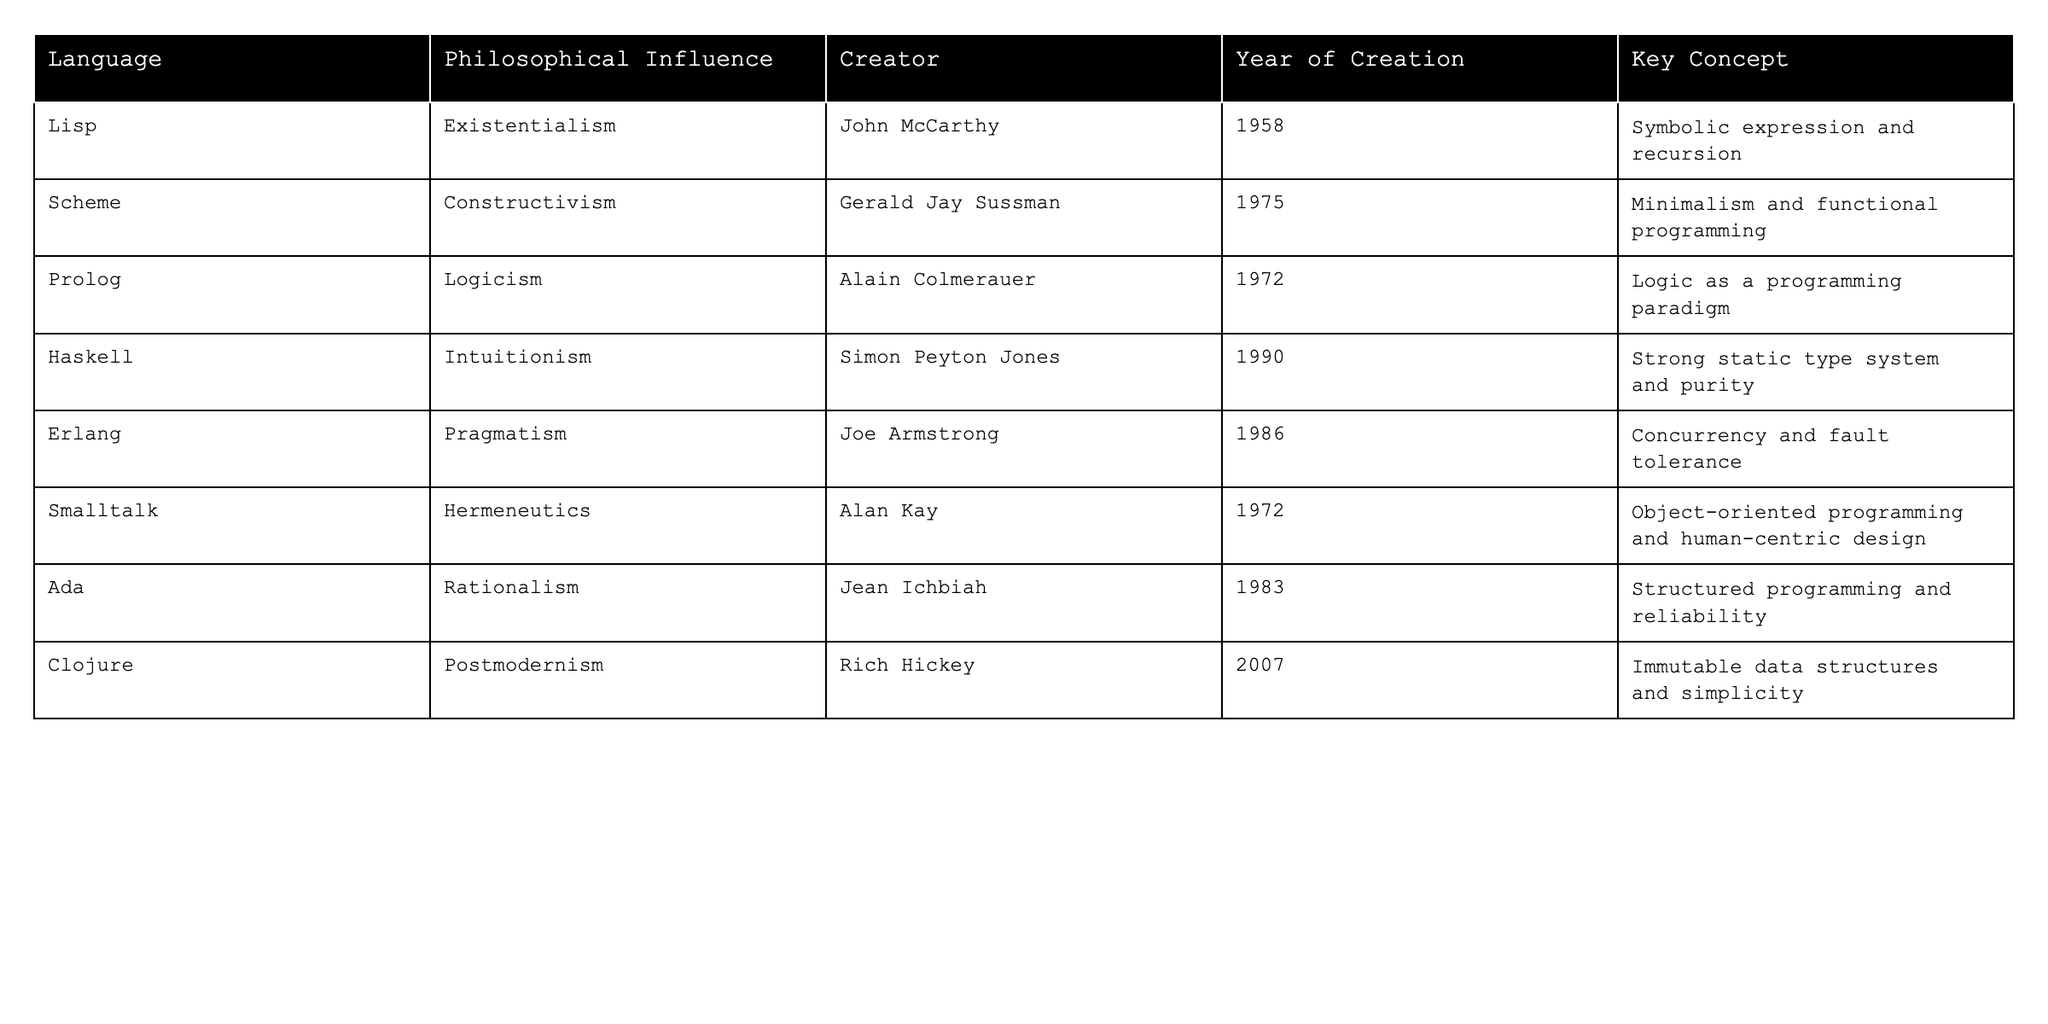What is the philosophical influence of Haskell? According to the table, Haskell is influenced by Intuitionism, as stated in the corresponding row.
Answer: Intuitionism Who created Lisp? The table shows that Lisp was created by John McCarthy, as specified in the column for creators.
Answer: John McCarthy In what year was Erlang created? By checking the table, Erlang was created in 1986, which is listed in the year of creation column.
Answer: 1986 Which programming language is associated with Pragmatism? The table indicates that Erlang is associated with Pragmatism, as noted in its respective row.
Answer: Erlang How many programming languages mentioned were created after 1980? From the table, the languages created after 1980 are Erlang (1986), Ada (1983), and Clojure (2007), making a total of three languages.
Answer: 3 Is there a programming language inspired by Logicism? The table indicates that Prolog is inspired by Logicism, confirming that there is at least one programming language influenced by this philosophy.
Answer: Yes What key concept is associated with Clojure? According to the table, Clojure's key concept is immutable data structures and simplicity, as stated in the key concept column.
Answer: Immutable data structures and simplicity Which programming language was created by Alan Kay? By reviewing the table, it is clear that Smalltalk was created by Alan Kay, as noted in the creator column.
Answer: Smalltalk What is the total number of programming languages listed in the table? There are eight programming languages listed in the table, as counted in the language column.
Answer: 8 Which programming language created in 1975 is minimalist in its approach? The table reveals that Scheme, created in 1975, follows a minimalist approach as its key concept is minimalism and functional programming.
Answer: Scheme How many languages focus on fault tolerance and concurrency? The table shows that Erlang focuses on concurrency and fault tolerance, thus there is only one language with this focus.
Answer: 1 